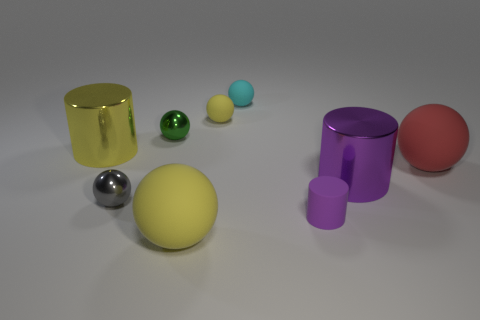Subtract 3 spheres. How many spheres are left? 3 Subtract all red spheres. How many spheres are left? 5 Subtract all tiny gray metal balls. How many balls are left? 5 Subtract all green cylinders. Subtract all yellow balls. How many cylinders are left? 3 Add 1 big blue metal cylinders. How many objects exist? 10 Subtract all balls. How many objects are left? 3 Add 5 tiny gray matte spheres. How many tiny gray matte spheres exist? 5 Subtract 0 purple spheres. How many objects are left? 9 Subtract all small red blocks. Subtract all big cylinders. How many objects are left? 7 Add 4 cyan rubber things. How many cyan rubber things are left? 5 